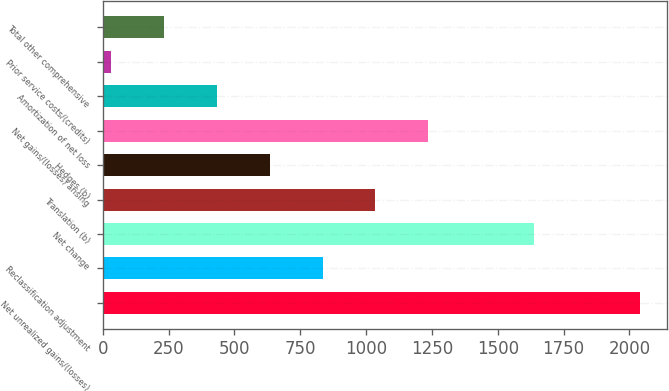Convert chart. <chart><loc_0><loc_0><loc_500><loc_500><bar_chart><fcel>Net unrealized gains/(losses)<fcel>Reclassification adjustment<fcel>Net change<fcel>Translation (b)<fcel>Hedges (b)<fcel>Net gains/(losses) arising<fcel>Amortization of net loss<fcel>Prior service costs/(credits)<fcel>Total other comprehensive<nl><fcel>2039<fcel>834.8<fcel>1637.6<fcel>1035.5<fcel>634.1<fcel>1236.2<fcel>433.4<fcel>32<fcel>232.7<nl></chart> 